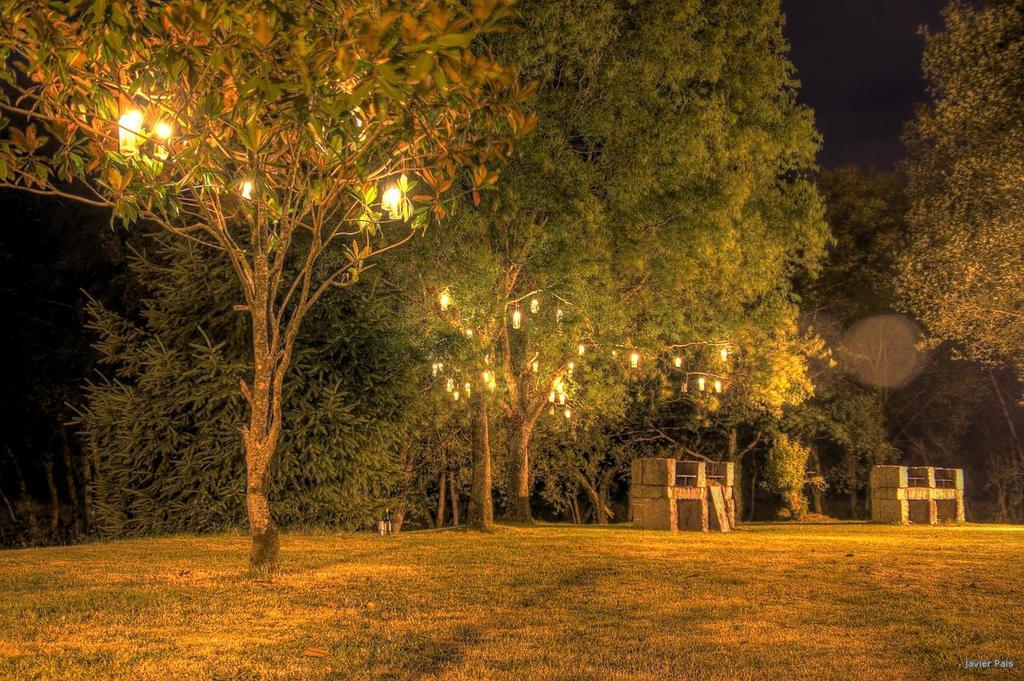What type of vegetation is at the bottom of the image? There is grass at the bottom of the image. What other natural elements can be seen in the image? There are trees in the image. What artificial elements are present in the image? There are lights in the image. How would you describe the overall lighting in the image? The background of the image is dark. Where can some text be found in the image? There is some text at the right bottom of the image. What type of hat is worn by the army personnel in the image? There is no army personnel or hat present in the image. What type of powder is used to create the lights in the image? The lights in the image are artificial and do not require any powder for their illumination. 